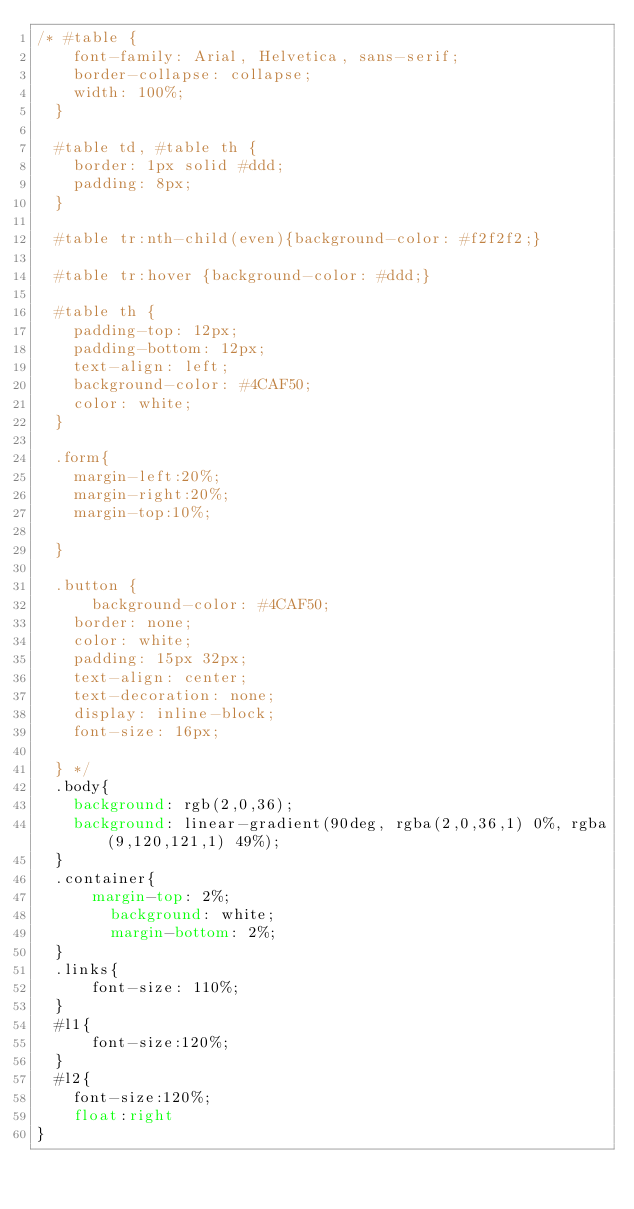Convert code to text. <code><loc_0><loc_0><loc_500><loc_500><_CSS_>/* #table {
    font-family: Arial, Helvetica, sans-serif;
    border-collapse: collapse;
    width: 100%;
  }
  
  #table td, #table th {
    border: 1px solid #ddd;
    padding: 8px;
  }
  
  #table tr:nth-child(even){background-color: #f2f2f2;}
  
  #table tr:hover {background-color: #ddd;}
  
  #table th {
    padding-top: 12px;
    padding-bottom: 12px;
    text-align: left;
    background-color: #4CAF50;
    color: white;
  }
  
  .form{
    margin-left:20%;
    margin-right:20%;
    margin-top:10%;
    
  }
  
  .button {
      background-color: #4CAF50; 
    border: none;
    color: white;
    padding: 15px 32px;
    text-align: center;
    text-decoration: none;
    display: inline-block;
    font-size: 16px;
    
  } */
  .body{
    background: rgb(2,0,36);
    background: linear-gradient(90deg, rgba(2,0,36,1) 0%, rgba(9,120,121,1) 49%);
  }
  .container{
      margin-top: 2%;
        background: white;
        margin-bottom: 2%;
  }
  .links{
      font-size: 110%;
  }
  #l1{
      font-size:120%;
  }
  #l2{
    font-size:120%;
    float:right
}</code> 